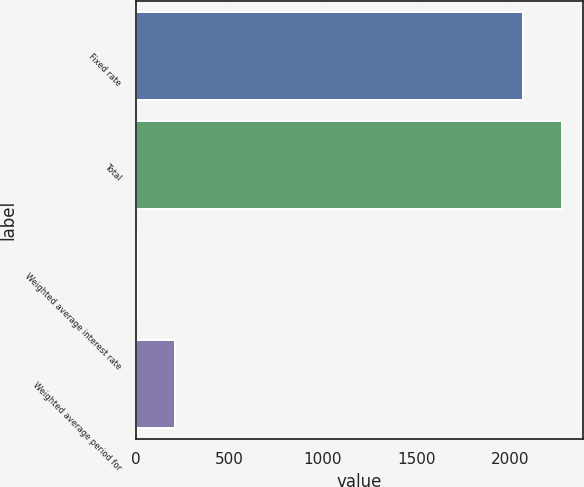<chart> <loc_0><loc_0><loc_500><loc_500><bar_chart><fcel>Fixed rate<fcel>Total<fcel>Weighted average interest rate<fcel>Weighted average period for<nl><fcel>2072.8<fcel>2279.68<fcel>4<fcel>210.88<nl></chart> 